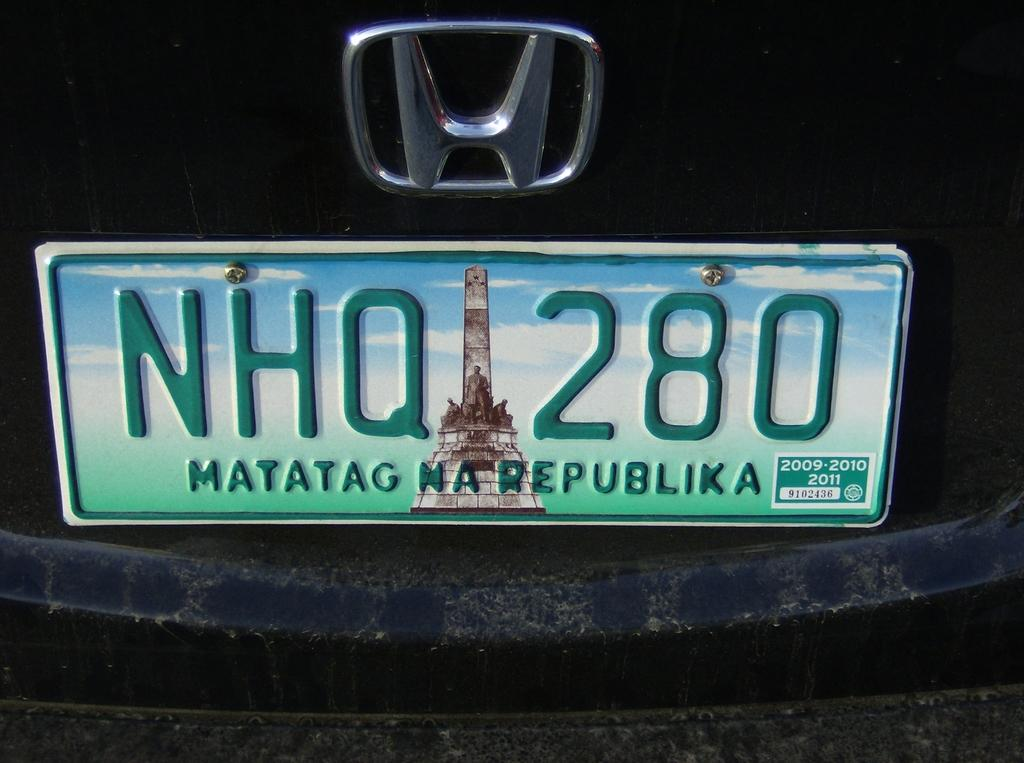<image>
Write a terse but informative summary of the picture. A license plate has NHQ 280 above the location MATATAG NA REPUBLIKA. 